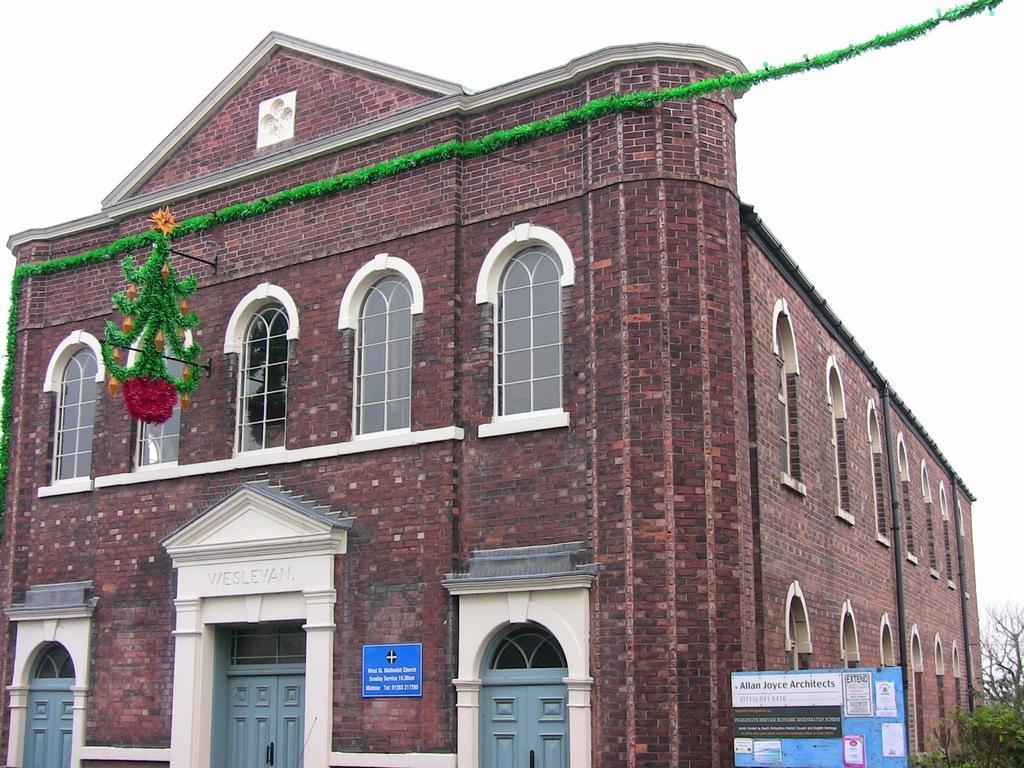Describe this image in one or two sentences. In the image we can see there is a building and the building is made up of red bricks. The building is decorated with green colour paper lace and behind there are trees. 